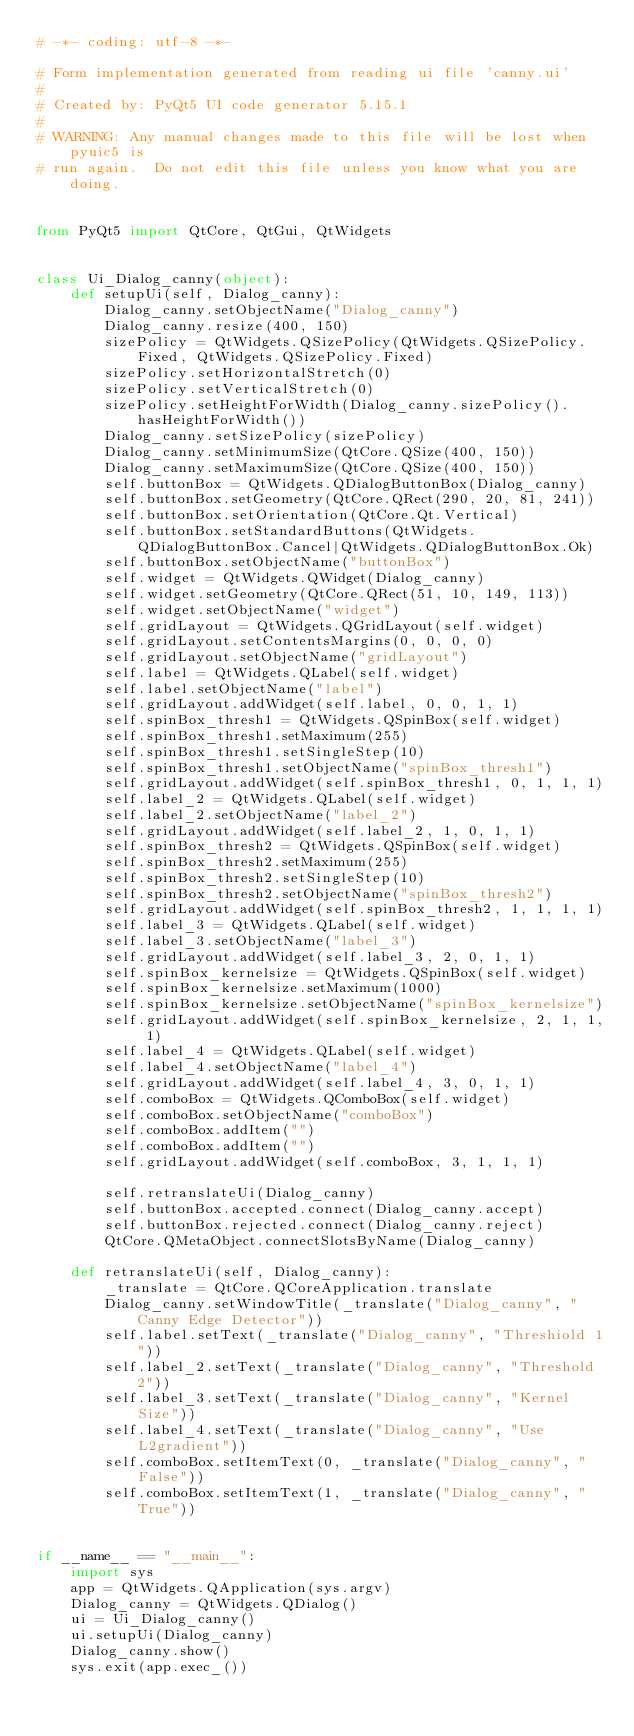Convert code to text. <code><loc_0><loc_0><loc_500><loc_500><_Python_># -*- coding: utf-8 -*-

# Form implementation generated from reading ui file 'canny.ui'
#
# Created by: PyQt5 UI code generator 5.15.1
#
# WARNING: Any manual changes made to this file will be lost when pyuic5 is
# run again.  Do not edit this file unless you know what you are doing.


from PyQt5 import QtCore, QtGui, QtWidgets


class Ui_Dialog_canny(object):
    def setupUi(self, Dialog_canny):
        Dialog_canny.setObjectName("Dialog_canny")
        Dialog_canny.resize(400, 150)
        sizePolicy = QtWidgets.QSizePolicy(QtWidgets.QSizePolicy.Fixed, QtWidgets.QSizePolicy.Fixed)
        sizePolicy.setHorizontalStretch(0)
        sizePolicy.setVerticalStretch(0)
        sizePolicy.setHeightForWidth(Dialog_canny.sizePolicy().hasHeightForWidth())
        Dialog_canny.setSizePolicy(sizePolicy)
        Dialog_canny.setMinimumSize(QtCore.QSize(400, 150))
        Dialog_canny.setMaximumSize(QtCore.QSize(400, 150))
        self.buttonBox = QtWidgets.QDialogButtonBox(Dialog_canny)
        self.buttonBox.setGeometry(QtCore.QRect(290, 20, 81, 241))
        self.buttonBox.setOrientation(QtCore.Qt.Vertical)
        self.buttonBox.setStandardButtons(QtWidgets.QDialogButtonBox.Cancel|QtWidgets.QDialogButtonBox.Ok)
        self.buttonBox.setObjectName("buttonBox")
        self.widget = QtWidgets.QWidget(Dialog_canny)
        self.widget.setGeometry(QtCore.QRect(51, 10, 149, 113))
        self.widget.setObjectName("widget")
        self.gridLayout = QtWidgets.QGridLayout(self.widget)
        self.gridLayout.setContentsMargins(0, 0, 0, 0)
        self.gridLayout.setObjectName("gridLayout")
        self.label = QtWidgets.QLabel(self.widget)
        self.label.setObjectName("label")
        self.gridLayout.addWidget(self.label, 0, 0, 1, 1)
        self.spinBox_thresh1 = QtWidgets.QSpinBox(self.widget)
        self.spinBox_thresh1.setMaximum(255)
        self.spinBox_thresh1.setSingleStep(10)
        self.spinBox_thresh1.setObjectName("spinBox_thresh1")
        self.gridLayout.addWidget(self.spinBox_thresh1, 0, 1, 1, 1)
        self.label_2 = QtWidgets.QLabel(self.widget)
        self.label_2.setObjectName("label_2")
        self.gridLayout.addWidget(self.label_2, 1, 0, 1, 1)
        self.spinBox_thresh2 = QtWidgets.QSpinBox(self.widget)
        self.spinBox_thresh2.setMaximum(255)
        self.spinBox_thresh2.setSingleStep(10)
        self.spinBox_thresh2.setObjectName("spinBox_thresh2")
        self.gridLayout.addWidget(self.spinBox_thresh2, 1, 1, 1, 1)
        self.label_3 = QtWidgets.QLabel(self.widget)
        self.label_3.setObjectName("label_3")
        self.gridLayout.addWidget(self.label_3, 2, 0, 1, 1)
        self.spinBox_kernelsize = QtWidgets.QSpinBox(self.widget)
        self.spinBox_kernelsize.setMaximum(1000)
        self.spinBox_kernelsize.setObjectName("spinBox_kernelsize")
        self.gridLayout.addWidget(self.spinBox_kernelsize, 2, 1, 1, 1)
        self.label_4 = QtWidgets.QLabel(self.widget)
        self.label_4.setObjectName("label_4")
        self.gridLayout.addWidget(self.label_4, 3, 0, 1, 1)
        self.comboBox = QtWidgets.QComboBox(self.widget)
        self.comboBox.setObjectName("comboBox")
        self.comboBox.addItem("")
        self.comboBox.addItem("")
        self.gridLayout.addWidget(self.comboBox, 3, 1, 1, 1)

        self.retranslateUi(Dialog_canny)
        self.buttonBox.accepted.connect(Dialog_canny.accept)
        self.buttonBox.rejected.connect(Dialog_canny.reject)
        QtCore.QMetaObject.connectSlotsByName(Dialog_canny)

    def retranslateUi(self, Dialog_canny):
        _translate = QtCore.QCoreApplication.translate
        Dialog_canny.setWindowTitle(_translate("Dialog_canny", "Canny Edge Detector"))
        self.label.setText(_translate("Dialog_canny", "Threshiold 1"))
        self.label_2.setText(_translate("Dialog_canny", "Threshold 2"))
        self.label_3.setText(_translate("Dialog_canny", "Kernel Size"))
        self.label_4.setText(_translate("Dialog_canny", "Use L2gradient"))
        self.comboBox.setItemText(0, _translate("Dialog_canny", "False"))
        self.comboBox.setItemText(1, _translate("Dialog_canny", "True"))


if __name__ == "__main__":
    import sys
    app = QtWidgets.QApplication(sys.argv)
    Dialog_canny = QtWidgets.QDialog()
    ui = Ui_Dialog_canny()
    ui.setupUi(Dialog_canny)
    Dialog_canny.show()
    sys.exit(app.exec_())
</code> 